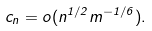Convert formula to latex. <formula><loc_0><loc_0><loc_500><loc_500>c _ { n } = o ( n ^ { 1 / 2 } m ^ { - 1 / 6 } ) .</formula> 